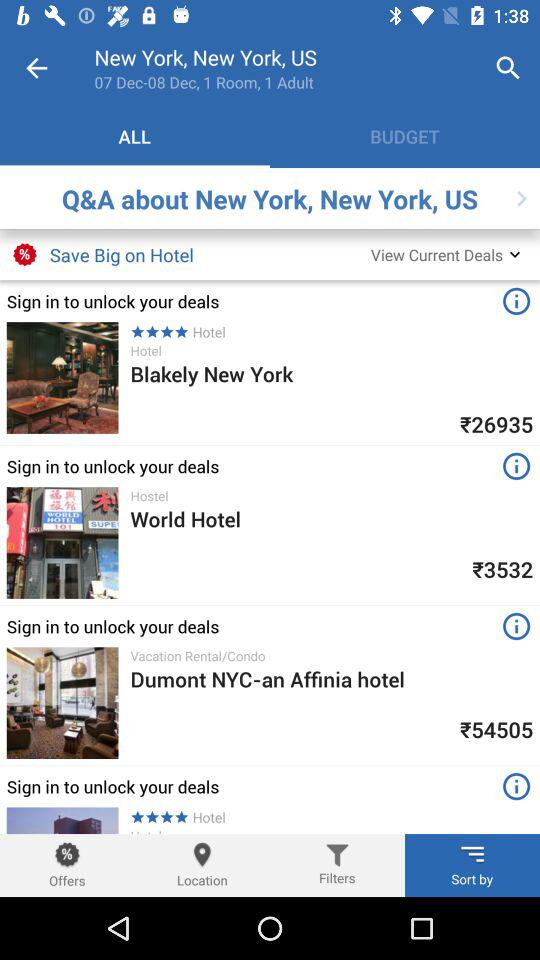For what dates is the person looking for a room? The dates are December 07 to December 08. 